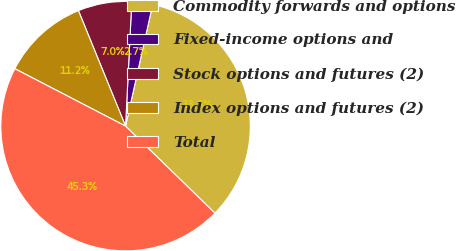<chart> <loc_0><loc_0><loc_500><loc_500><pie_chart><fcel>Commodity forwards and options<fcel>Fixed-income options and<fcel>Stock options and futures (2)<fcel>Index options and futures (2)<fcel>Total<nl><fcel>33.8%<fcel>2.7%<fcel>6.96%<fcel>11.22%<fcel>45.32%<nl></chart> 